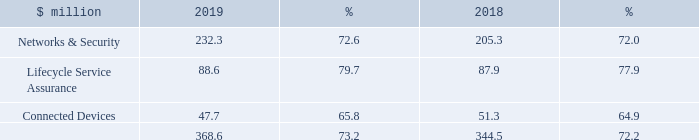Gross margin
The Group achieved further gross margin expansion in 2019 with an increase of 1.0 percentage points, to 73.2 per cent from 72.2 per cent in 2018. This followed an increase of 0.7 percentage points last year. Once again, all the operating segments achieved an improvement in gross margin, benefiting from new product launches and a higher proportion of software sales.
What was the gross margin in 2019?
Answer scale should be: million. 368.6. What was the gross margin in 2018?
Answer scale should be: million. 344.5. Which operating segments in the table achieved an improvement in gross margin? Networks & security, lifecycle service assurance, connected devices. In which year was the amount of gross profit for Connected Devices larger? 51.3>47.7
Answer: 2018. What was the change in the amount of gross profits?
Answer scale should be: million. 368.6-344.5
Answer: 24.1. What was the percentage change in the amount of gross profits?
Answer scale should be: percent. (368.6-344.5)/344.5
Answer: 7. 